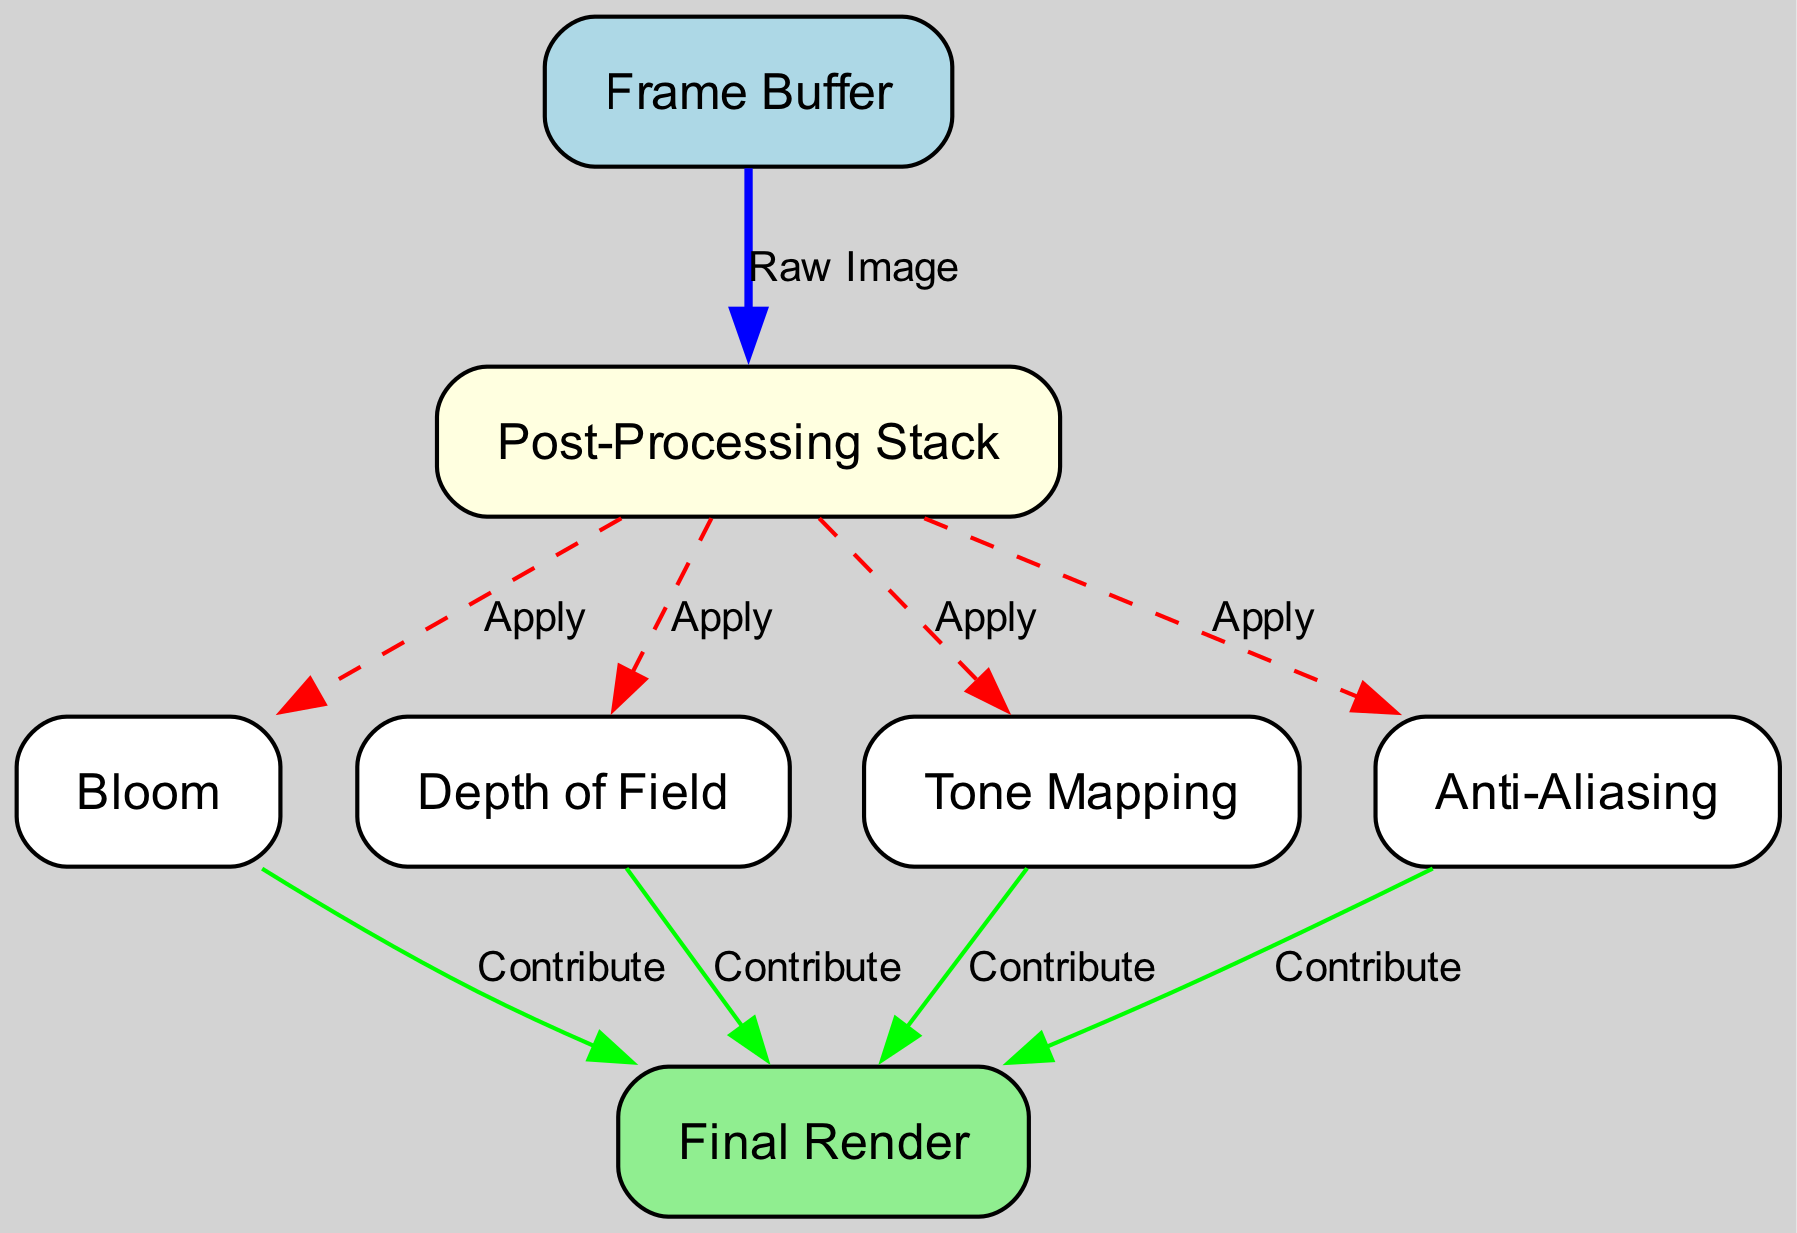What is the first node in the workflow? The first node is the 'Frame Buffer,' which is where the raw image is captured before any post-processing effects are applied.
Answer: Frame Buffer How many post-processing effects are applied in the workflow? There are four post-processing effects: Bloom, Depth of Field, Tone Mapping, and Anti-Aliasing, which are all connected to the Post-Processing Stack.
Answer: Four What is the final output node called? The final node after all post-processing effects is the 'Final Render,' which combines contributions from the different effects.
Answer: Final Render What type of relationship is indicated between the 'Post-Processing Stack' and 'Bloom'? The relationship is labeled 'Apply,' indicating that the Bloom effect is applied during the post-processing stage after the raw image.
Answer: Apply Which node contributes to the 'Final Render'? The nodes contributing to the 'Final Render' are Bloom, Depth of Field, Tone Mapping, and Anti-Aliasing, each providing their processed output.
Answer: Bloom, Depth of Field, Tone Mapping, Anti-Aliasing Which edge represents the flow of the raw image? The edge labeled 'Raw Image' indicates the flow from the 'Frame Buffer' to the 'Post-Processing Stack,' showing how the initial image enters the processing stage.
Answer: Raw Image In what color is the 'Post-Processing Stack' node represented? The 'Post-Processing Stack' node is represented in light yellow, distinguishing it from other nodes in the diagram.
Answer: Light yellow What color signifies the 'Apply' relationship edges? The edges labeled 'Apply' are colored red and are styled as dashed lines, indicating actions taken during the post-processing steps.
Answer: Red Which nodes are connected to the 'Final Render' node? The nodes connected to the 'Final Render' node are Bloom, Depth of Field, Tone Mapping, and Anti-Aliasing, contributing to the final output image.
Answer: Bloom, Depth of Field, Tone Mapping, Anti-Aliasing 